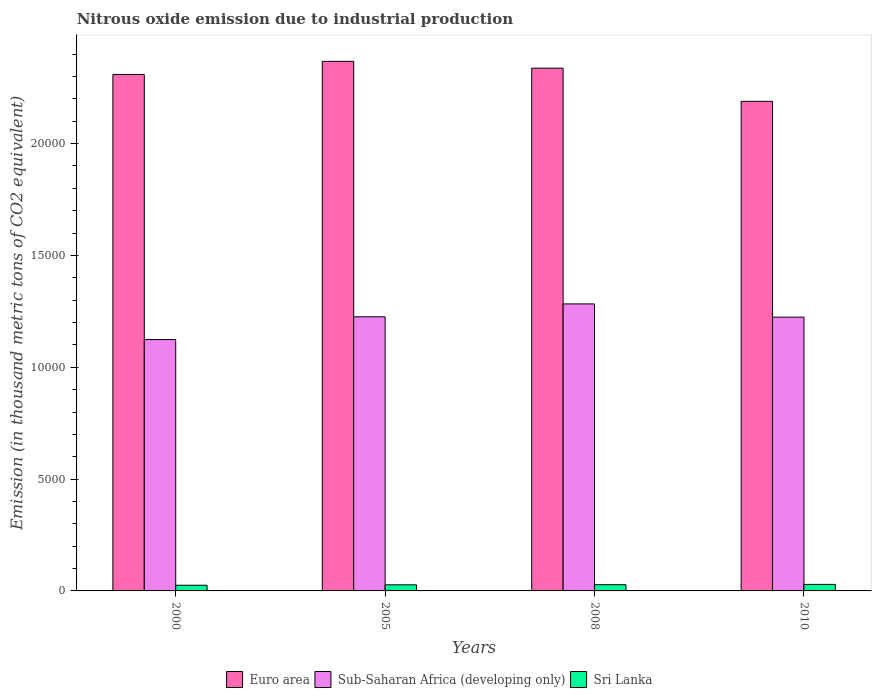How many different coloured bars are there?
Keep it short and to the point. 3. How many bars are there on the 2nd tick from the left?
Offer a very short reply. 3. How many bars are there on the 2nd tick from the right?
Your answer should be compact. 3. What is the label of the 1st group of bars from the left?
Ensure brevity in your answer.  2000. In how many cases, is the number of bars for a given year not equal to the number of legend labels?
Give a very brief answer. 0. What is the amount of nitrous oxide emitted in Sri Lanka in 2005?
Ensure brevity in your answer.  271.8. Across all years, what is the maximum amount of nitrous oxide emitted in Euro area?
Offer a very short reply. 2.37e+04. Across all years, what is the minimum amount of nitrous oxide emitted in Sub-Saharan Africa (developing only)?
Offer a terse response. 1.12e+04. What is the total amount of nitrous oxide emitted in Euro area in the graph?
Keep it short and to the point. 9.20e+04. What is the difference between the amount of nitrous oxide emitted in Euro area in 2005 and that in 2008?
Provide a succinct answer. 305.7. What is the difference between the amount of nitrous oxide emitted in Sub-Saharan Africa (developing only) in 2008 and the amount of nitrous oxide emitted in Sri Lanka in 2010?
Offer a very short reply. 1.25e+04. What is the average amount of nitrous oxide emitted in Sri Lanka per year?
Ensure brevity in your answer.  274.12. In the year 2005, what is the difference between the amount of nitrous oxide emitted in Sri Lanka and amount of nitrous oxide emitted in Euro area?
Ensure brevity in your answer.  -2.34e+04. What is the ratio of the amount of nitrous oxide emitted in Sub-Saharan Africa (developing only) in 2000 to that in 2008?
Keep it short and to the point. 0.88. Is the amount of nitrous oxide emitted in Sri Lanka in 2000 less than that in 2005?
Provide a short and direct response. Yes. What is the difference between the highest and the second highest amount of nitrous oxide emitted in Euro area?
Make the answer very short. 305.7. What is the difference between the highest and the lowest amount of nitrous oxide emitted in Sub-Saharan Africa (developing only)?
Keep it short and to the point. 1594.7. In how many years, is the amount of nitrous oxide emitted in Sri Lanka greater than the average amount of nitrous oxide emitted in Sri Lanka taken over all years?
Give a very brief answer. 2. What does the 2nd bar from the left in 2000 represents?
Give a very brief answer. Sub-Saharan Africa (developing only). What does the 2nd bar from the right in 2008 represents?
Offer a terse response. Sub-Saharan Africa (developing only). Is it the case that in every year, the sum of the amount of nitrous oxide emitted in Sub-Saharan Africa (developing only) and amount of nitrous oxide emitted in Euro area is greater than the amount of nitrous oxide emitted in Sri Lanka?
Your response must be concise. Yes. Are all the bars in the graph horizontal?
Provide a short and direct response. No. Are the values on the major ticks of Y-axis written in scientific E-notation?
Provide a succinct answer. No. Does the graph contain any zero values?
Offer a terse response. No. Does the graph contain grids?
Give a very brief answer. No. Where does the legend appear in the graph?
Make the answer very short. Bottom center. How many legend labels are there?
Your response must be concise. 3. What is the title of the graph?
Your response must be concise. Nitrous oxide emission due to industrial production. Does "Kenya" appear as one of the legend labels in the graph?
Provide a succinct answer. No. What is the label or title of the Y-axis?
Make the answer very short. Emission (in thousand metric tons of CO2 equivalent). What is the Emission (in thousand metric tons of CO2 equivalent) of Euro area in 2000?
Offer a terse response. 2.31e+04. What is the Emission (in thousand metric tons of CO2 equivalent) in Sub-Saharan Africa (developing only) in 2000?
Offer a very short reply. 1.12e+04. What is the Emission (in thousand metric tons of CO2 equivalent) in Sri Lanka in 2000?
Your answer should be very brief. 254. What is the Emission (in thousand metric tons of CO2 equivalent) of Euro area in 2005?
Offer a very short reply. 2.37e+04. What is the Emission (in thousand metric tons of CO2 equivalent) in Sub-Saharan Africa (developing only) in 2005?
Provide a short and direct response. 1.23e+04. What is the Emission (in thousand metric tons of CO2 equivalent) of Sri Lanka in 2005?
Your response must be concise. 271.8. What is the Emission (in thousand metric tons of CO2 equivalent) of Euro area in 2008?
Provide a succinct answer. 2.34e+04. What is the Emission (in thousand metric tons of CO2 equivalent) in Sub-Saharan Africa (developing only) in 2008?
Your answer should be compact. 1.28e+04. What is the Emission (in thousand metric tons of CO2 equivalent) of Sri Lanka in 2008?
Keep it short and to the point. 278.3. What is the Emission (in thousand metric tons of CO2 equivalent) in Euro area in 2010?
Ensure brevity in your answer.  2.19e+04. What is the Emission (in thousand metric tons of CO2 equivalent) in Sub-Saharan Africa (developing only) in 2010?
Your response must be concise. 1.22e+04. What is the Emission (in thousand metric tons of CO2 equivalent) in Sri Lanka in 2010?
Make the answer very short. 292.4. Across all years, what is the maximum Emission (in thousand metric tons of CO2 equivalent) of Euro area?
Ensure brevity in your answer.  2.37e+04. Across all years, what is the maximum Emission (in thousand metric tons of CO2 equivalent) in Sub-Saharan Africa (developing only)?
Give a very brief answer. 1.28e+04. Across all years, what is the maximum Emission (in thousand metric tons of CO2 equivalent) in Sri Lanka?
Keep it short and to the point. 292.4. Across all years, what is the minimum Emission (in thousand metric tons of CO2 equivalent) in Euro area?
Your answer should be compact. 2.19e+04. Across all years, what is the minimum Emission (in thousand metric tons of CO2 equivalent) in Sub-Saharan Africa (developing only)?
Provide a succinct answer. 1.12e+04. Across all years, what is the minimum Emission (in thousand metric tons of CO2 equivalent) of Sri Lanka?
Provide a succinct answer. 254. What is the total Emission (in thousand metric tons of CO2 equivalent) in Euro area in the graph?
Make the answer very short. 9.20e+04. What is the total Emission (in thousand metric tons of CO2 equivalent) in Sub-Saharan Africa (developing only) in the graph?
Provide a succinct answer. 4.86e+04. What is the total Emission (in thousand metric tons of CO2 equivalent) of Sri Lanka in the graph?
Ensure brevity in your answer.  1096.5. What is the difference between the Emission (in thousand metric tons of CO2 equivalent) of Euro area in 2000 and that in 2005?
Give a very brief answer. -585.9. What is the difference between the Emission (in thousand metric tons of CO2 equivalent) of Sub-Saharan Africa (developing only) in 2000 and that in 2005?
Provide a succinct answer. -1018.1. What is the difference between the Emission (in thousand metric tons of CO2 equivalent) of Sri Lanka in 2000 and that in 2005?
Provide a short and direct response. -17.8. What is the difference between the Emission (in thousand metric tons of CO2 equivalent) in Euro area in 2000 and that in 2008?
Your response must be concise. -280.2. What is the difference between the Emission (in thousand metric tons of CO2 equivalent) of Sub-Saharan Africa (developing only) in 2000 and that in 2008?
Provide a short and direct response. -1594.7. What is the difference between the Emission (in thousand metric tons of CO2 equivalent) in Sri Lanka in 2000 and that in 2008?
Your answer should be very brief. -24.3. What is the difference between the Emission (in thousand metric tons of CO2 equivalent) of Euro area in 2000 and that in 2010?
Keep it short and to the point. 1202.1. What is the difference between the Emission (in thousand metric tons of CO2 equivalent) of Sub-Saharan Africa (developing only) in 2000 and that in 2010?
Provide a succinct answer. -1003.5. What is the difference between the Emission (in thousand metric tons of CO2 equivalent) in Sri Lanka in 2000 and that in 2010?
Offer a terse response. -38.4. What is the difference between the Emission (in thousand metric tons of CO2 equivalent) of Euro area in 2005 and that in 2008?
Give a very brief answer. 305.7. What is the difference between the Emission (in thousand metric tons of CO2 equivalent) in Sub-Saharan Africa (developing only) in 2005 and that in 2008?
Give a very brief answer. -576.6. What is the difference between the Emission (in thousand metric tons of CO2 equivalent) of Euro area in 2005 and that in 2010?
Your response must be concise. 1788. What is the difference between the Emission (in thousand metric tons of CO2 equivalent) in Sub-Saharan Africa (developing only) in 2005 and that in 2010?
Provide a short and direct response. 14.6. What is the difference between the Emission (in thousand metric tons of CO2 equivalent) of Sri Lanka in 2005 and that in 2010?
Your answer should be compact. -20.6. What is the difference between the Emission (in thousand metric tons of CO2 equivalent) of Euro area in 2008 and that in 2010?
Give a very brief answer. 1482.3. What is the difference between the Emission (in thousand metric tons of CO2 equivalent) in Sub-Saharan Africa (developing only) in 2008 and that in 2010?
Offer a very short reply. 591.2. What is the difference between the Emission (in thousand metric tons of CO2 equivalent) of Sri Lanka in 2008 and that in 2010?
Keep it short and to the point. -14.1. What is the difference between the Emission (in thousand metric tons of CO2 equivalent) of Euro area in 2000 and the Emission (in thousand metric tons of CO2 equivalent) of Sub-Saharan Africa (developing only) in 2005?
Offer a terse response. 1.08e+04. What is the difference between the Emission (in thousand metric tons of CO2 equivalent) of Euro area in 2000 and the Emission (in thousand metric tons of CO2 equivalent) of Sri Lanka in 2005?
Ensure brevity in your answer.  2.28e+04. What is the difference between the Emission (in thousand metric tons of CO2 equivalent) of Sub-Saharan Africa (developing only) in 2000 and the Emission (in thousand metric tons of CO2 equivalent) of Sri Lanka in 2005?
Your response must be concise. 1.10e+04. What is the difference between the Emission (in thousand metric tons of CO2 equivalent) of Euro area in 2000 and the Emission (in thousand metric tons of CO2 equivalent) of Sub-Saharan Africa (developing only) in 2008?
Keep it short and to the point. 1.03e+04. What is the difference between the Emission (in thousand metric tons of CO2 equivalent) of Euro area in 2000 and the Emission (in thousand metric tons of CO2 equivalent) of Sri Lanka in 2008?
Offer a terse response. 2.28e+04. What is the difference between the Emission (in thousand metric tons of CO2 equivalent) in Sub-Saharan Africa (developing only) in 2000 and the Emission (in thousand metric tons of CO2 equivalent) in Sri Lanka in 2008?
Offer a terse response. 1.10e+04. What is the difference between the Emission (in thousand metric tons of CO2 equivalent) in Euro area in 2000 and the Emission (in thousand metric tons of CO2 equivalent) in Sub-Saharan Africa (developing only) in 2010?
Provide a short and direct response. 1.09e+04. What is the difference between the Emission (in thousand metric tons of CO2 equivalent) in Euro area in 2000 and the Emission (in thousand metric tons of CO2 equivalent) in Sri Lanka in 2010?
Offer a very short reply. 2.28e+04. What is the difference between the Emission (in thousand metric tons of CO2 equivalent) in Sub-Saharan Africa (developing only) in 2000 and the Emission (in thousand metric tons of CO2 equivalent) in Sri Lanka in 2010?
Make the answer very short. 1.09e+04. What is the difference between the Emission (in thousand metric tons of CO2 equivalent) in Euro area in 2005 and the Emission (in thousand metric tons of CO2 equivalent) in Sub-Saharan Africa (developing only) in 2008?
Ensure brevity in your answer.  1.08e+04. What is the difference between the Emission (in thousand metric tons of CO2 equivalent) of Euro area in 2005 and the Emission (in thousand metric tons of CO2 equivalent) of Sri Lanka in 2008?
Offer a very short reply. 2.34e+04. What is the difference between the Emission (in thousand metric tons of CO2 equivalent) in Sub-Saharan Africa (developing only) in 2005 and the Emission (in thousand metric tons of CO2 equivalent) in Sri Lanka in 2008?
Your answer should be very brief. 1.20e+04. What is the difference between the Emission (in thousand metric tons of CO2 equivalent) of Euro area in 2005 and the Emission (in thousand metric tons of CO2 equivalent) of Sub-Saharan Africa (developing only) in 2010?
Your answer should be compact. 1.14e+04. What is the difference between the Emission (in thousand metric tons of CO2 equivalent) of Euro area in 2005 and the Emission (in thousand metric tons of CO2 equivalent) of Sri Lanka in 2010?
Your response must be concise. 2.34e+04. What is the difference between the Emission (in thousand metric tons of CO2 equivalent) of Sub-Saharan Africa (developing only) in 2005 and the Emission (in thousand metric tons of CO2 equivalent) of Sri Lanka in 2010?
Offer a terse response. 1.20e+04. What is the difference between the Emission (in thousand metric tons of CO2 equivalent) of Euro area in 2008 and the Emission (in thousand metric tons of CO2 equivalent) of Sub-Saharan Africa (developing only) in 2010?
Ensure brevity in your answer.  1.11e+04. What is the difference between the Emission (in thousand metric tons of CO2 equivalent) in Euro area in 2008 and the Emission (in thousand metric tons of CO2 equivalent) in Sri Lanka in 2010?
Provide a short and direct response. 2.31e+04. What is the difference between the Emission (in thousand metric tons of CO2 equivalent) of Sub-Saharan Africa (developing only) in 2008 and the Emission (in thousand metric tons of CO2 equivalent) of Sri Lanka in 2010?
Your response must be concise. 1.25e+04. What is the average Emission (in thousand metric tons of CO2 equivalent) of Euro area per year?
Give a very brief answer. 2.30e+04. What is the average Emission (in thousand metric tons of CO2 equivalent) in Sub-Saharan Africa (developing only) per year?
Offer a terse response. 1.21e+04. What is the average Emission (in thousand metric tons of CO2 equivalent) in Sri Lanka per year?
Your answer should be compact. 274.12. In the year 2000, what is the difference between the Emission (in thousand metric tons of CO2 equivalent) in Euro area and Emission (in thousand metric tons of CO2 equivalent) in Sub-Saharan Africa (developing only)?
Provide a short and direct response. 1.19e+04. In the year 2000, what is the difference between the Emission (in thousand metric tons of CO2 equivalent) in Euro area and Emission (in thousand metric tons of CO2 equivalent) in Sri Lanka?
Your answer should be compact. 2.28e+04. In the year 2000, what is the difference between the Emission (in thousand metric tons of CO2 equivalent) of Sub-Saharan Africa (developing only) and Emission (in thousand metric tons of CO2 equivalent) of Sri Lanka?
Keep it short and to the point. 1.10e+04. In the year 2005, what is the difference between the Emission (in thousand metric tons of CO2 equivalent) of Euro area and Emission (in thousand metric tons of CO2 equivalent) of Sub-Saharan Africa (developing only)?
Give a very brief answer. 1.14e+04. In the year 2005, what is the difference between the Emission (in thousand metric tons of CO2 equivalent) of Euro area and Emission (in thousand metric tons of CO2 equivalent) of Sri Lanka?
Make the answer very short. 2.34e+04. In the year 2005, what is the difference between the Emission (in thousand metric tons of CO2 equivalent) of Sub-Saharan Africa (developing only) and Emission (in thousand metric tons of CO2 equivalent) of Sri Lanka?
Give a very brief answer. 1.20e+04. In the year 2008, what is the difference between the Emission (in thousand metric tons of CO2 equivalent) of Euro area and Emission (in thousand metric tons of CO2 equivalent) of Sub-Saharan Africa (developing only)?
Your answer should be compact. 1.05e+04. In the year 2008, what is the difference between the Emission (in thousand metric tons of CO2 equivalent) in Euro area and Emission (in thousand metric tons of CO2 equivalent) in Sri Lanka?
Provide a short and direct response. 2.31e+04. In the year 2008, what is the difference between the Emission (in thousand metric tons of CO2 equivalent) in Sub-Saharan Africa (developing only) and Emission (in thousand metric tons of CO2 equivalent) in Sri Lanka?
Keep it short and to the point. 1.26e+04. In the year 2010, what is the difference between the Emission (in thousand metric tons of CO2 equivalent) in Euro area and Emission (in thousand metric tons of CO2 equivalent) in Sub-Saharan Africa (developing only)?
Your answer should be compact. 9648.8. In the year 2010, what is the difference between the Emission (in thousand metric tons of CO2 equivalent) in Euro area and Emission (in thousand metric tons of CO2 equivalent) in Sri Lanka?
Give a very brief answer. 2.16e+04. In the year 2010, what is the difference between the Emission (in thousand metric tons of CO2 equivalent) of Sub-Saharan Africa (developing only) and Emission (in thousand metric tons of CO2 equivalent) of Sri Lanka?
Offer a very short reply. 1.19e+04. What is the ratio of the Emission (in thousand metric tons of CO2 equivalent) in Euro area in 2000 to that in 2005?
Offer a very short reply. 0.98. What is the ratio of the Emission (in thousand metric tons of CO2 equivalent) in Sub-Saharan Africa (developing only) in 2000 to that in 2005?
Your response must be concise. 0.92. What is the ratio of the Emission (in thousand metric tons of CO2 equivalent) of Sri Lanka in 2000 to that in 2005?
Keep it short and to the point. 0.93. What is the ratio of the Emission (in thousand metric tons of CO2 equivalent) in Euro area in 2000 to that in 2008?
Provide a succinct answer. 0.99. What is the ratio of the Emission (in thousand metric tons of CO2 equivalent) of Sub-Saharan Africa (developing only) in 2000 to that in 2008?
Provide a short and direct response. 0.88. What is the ratio of the Emission (in thousand metric tons of CO2 equivalent) in Sri Lanka in 2000 to that in 2008?
Provide a succinct answer. 0.91. What is the ratio of the Emission (in thousand metric tons of CO2 equivalent) of Euro area in 2000 to that in 2010?
Make the answer very short. 1.05. What is the ratio of the Emission (in thousand metric tons of CO2 equivalent) of Sub-Saharan Africa (developing only) in 2000 to that in 2010?
Your response must be concise. 0.92. What is the ratio of the Emission (in thousand metric tons of CO2 equivalent) in Sri Lanka in 2000 to that in 2010?
Ensure brevity in your answer.  0.87. What is the ratio of the Emission (in thousand metric tons of CO2 equivalent) in Euro area in 2005 to that in 2008?
Ensure brevity in your answer.  1.01. What is the ratio of the Emission (in thousand metric tons of CO2 equivalent) in Sub-Saharan Africa (developing only) in 2005 to that in 2008?
Your answer should be very brief. 0.96. What is the ratio of the Emission (in thousand metric tons of CO2 equivalent) of Sri Lanka in 2005 to that in 2008?
Keep it short and to the point. 0.98. What is the ratio of the Emission (in thousand metric tons of CO2 equivalent) of Euro area in 2005 to that in 2010?
Make the answer very short. 1.08. What is the ratio of the Emission (in thousand metric tons of CO2 equivalent) in Sub-Saharan Africa (developing only) in 2005 to that in 2010?
Your response must be concise. 1. What is the ratio of the Emission (in thousand metric tons of CO2 equivalent) of Sri Lanka in 2005 to that in 2010?
Offer a terse response. 0.93. What is the ratio of the Emission (in thousand metric tons of CO2 equivalent) in Euro area in 2008 to that in 2010?
Make the answer very short. 1.07. What is the ratio of the Emission (in thousand metric tons of CO2 equivalent) in Sub-Saharan Africa (developing only) in 2008 to that in 2010?
Ensure brevity in your answer.  1.05. What is the ratio of the Emission (in thousand metric tons of CO2 equivalent) in Sri Lanka in 2008 to that in 2010?
Make the answer very short. 0.95. What is the difference between the highest and the second highest Emission (in thousand metric tons of CO2 equivalent) of Euro area?
Your answer should be compact. 305.7. What is the difference between the highest and the second highest Emission (in thousand metric tons of CO2 equivalent) of Sub-Saharan Africa (developing only)?
Ensure brevity in your answer.  576.6. What is the difference between the highest and the lowest Emission (in thousand metric tons of CO2 equivalent) of Euro area?
Give a very brief answer. 1788. What is the difference between the highest and the lowest Emission (in thousand metric tons of CO2 equivalent) of Sub-Saharan Africa (developing only)?
Offer a very short reply. 1594.7. What is the difference between the highest and the lowest Emission (in thousand metric tons of CO2 equivalent) in Sri Lanka?
Make the answer very short. 38.4. 